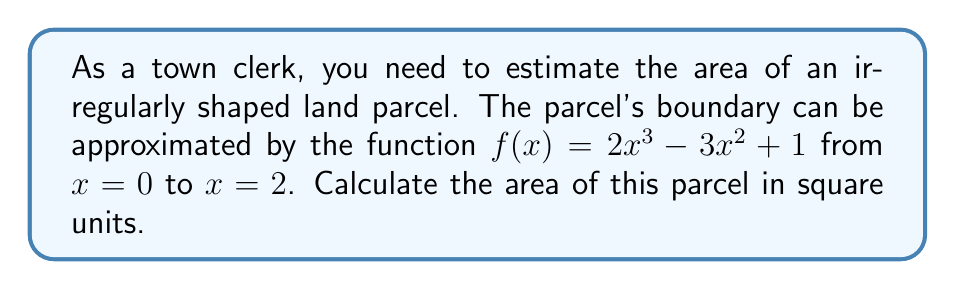Solve this math problem. To estimate the area of the irregularly shaped land parcel, we need to use integration techniques. The process is as follows:

1) The area under a curve $f(x)$ from $x = a$ to $x = b$ is given by the definite integral:

   $$A = \int_a^b f(x) dx$$

2) In this case, we have:
   $f(x) = 2x^3 - 3x^2 + 1$
   $a = 0$
   $b = 2$

3) Let's set up the integral:

   $$A = \int_0^2 (2x^3 - 3x^2 + 1) dx$$

4) To solve this, we integrate each term:

   $$A = \left[\frac{1}{2}x^4 - x^3 + x\right]_0^2$$

5) Now we evaluate the integral at the upper and lower bounds:

   $$A = \left(\frac{1}{2}(2^4) - (2^3) + 2\right) - \left(\frac{1}{2}(0^4) - (0^3) + 0\right)$$

6) Simplify:

   $$A = (8 - 8 + 2) - (0 - 0 + 0) = 2$$

Therefore, the area of the land parcel is 2 square units.
Answer: 2 square units 